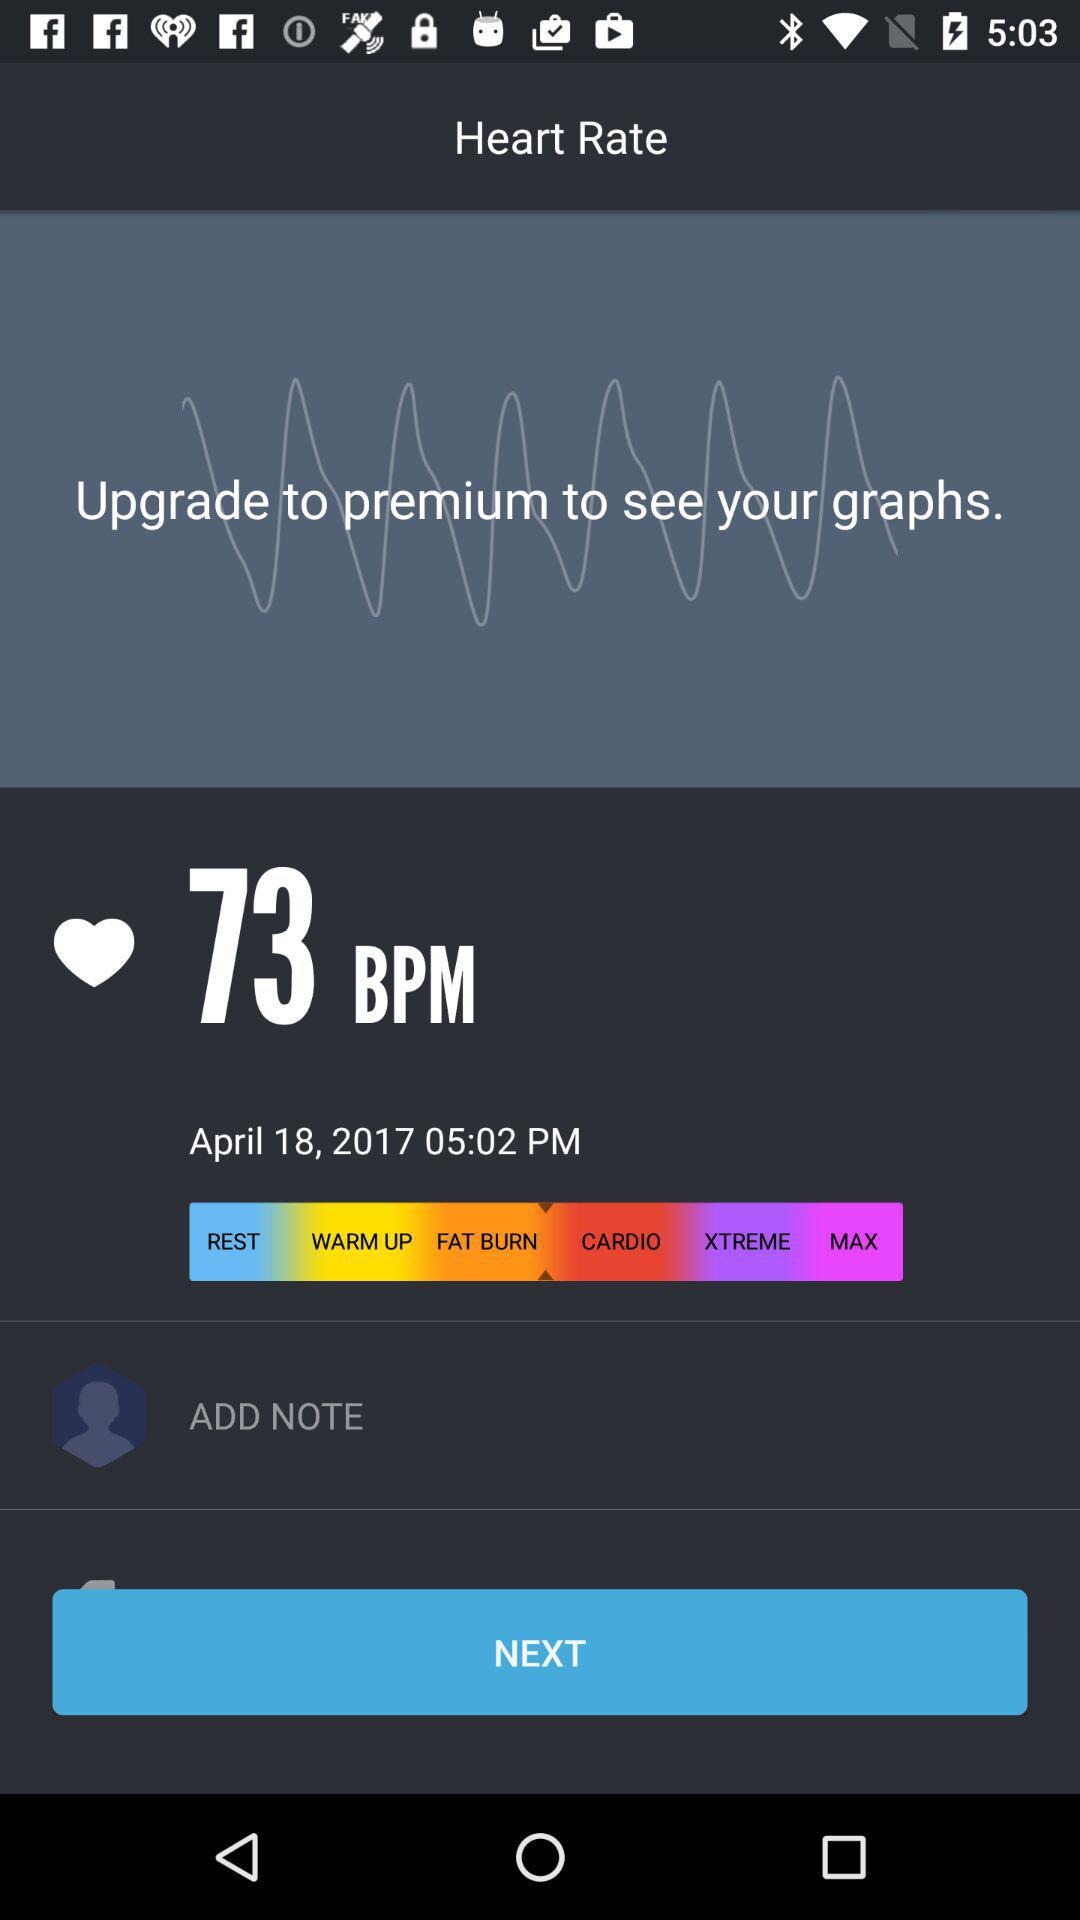What is the heart rate? The heart rate is 73 BPM. 